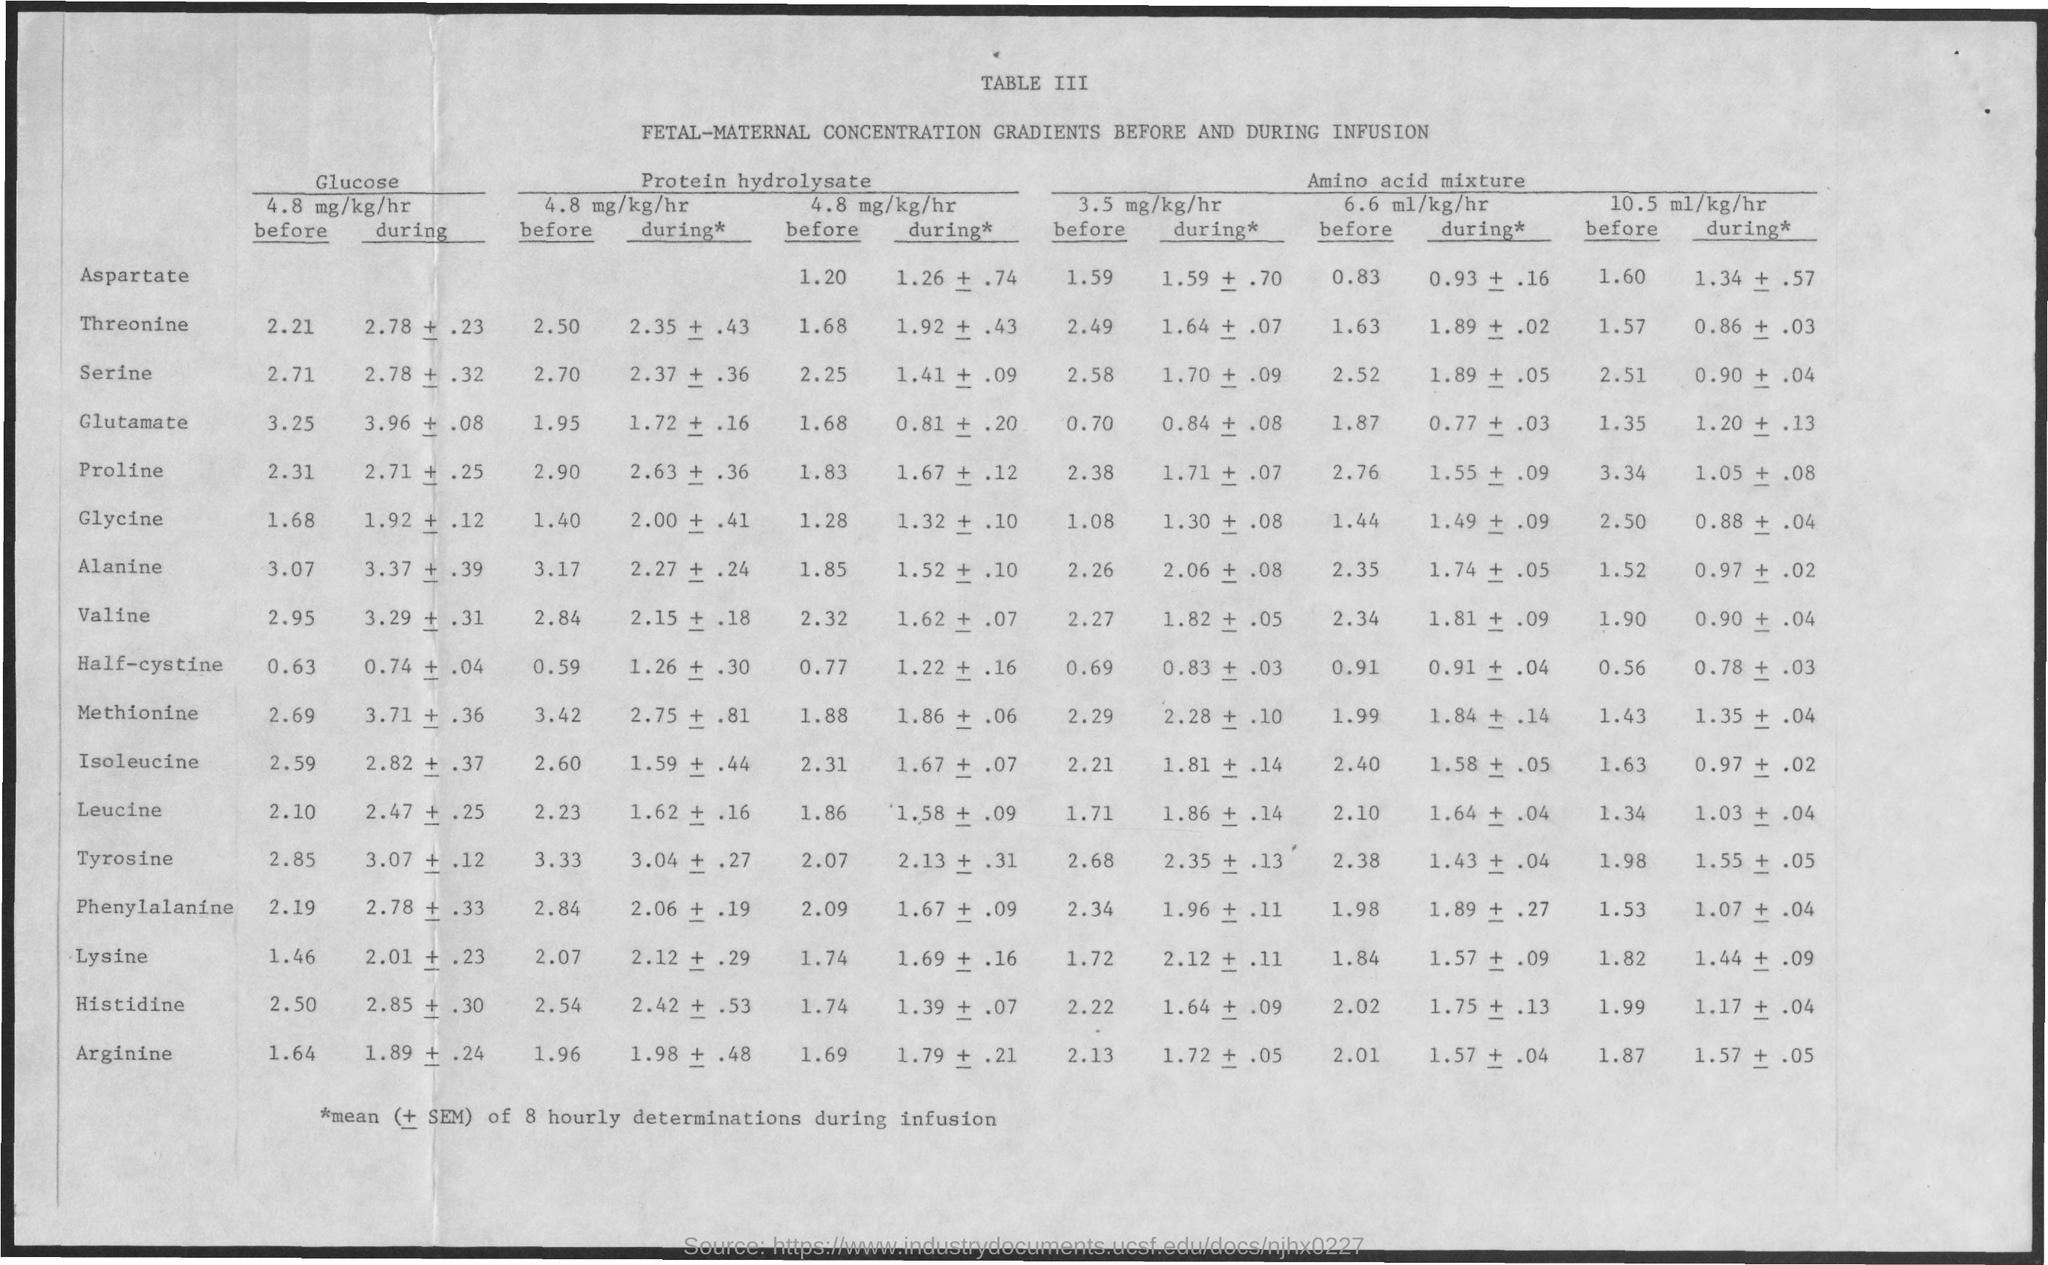What is the table number?
Provide a succinct answer. III. 